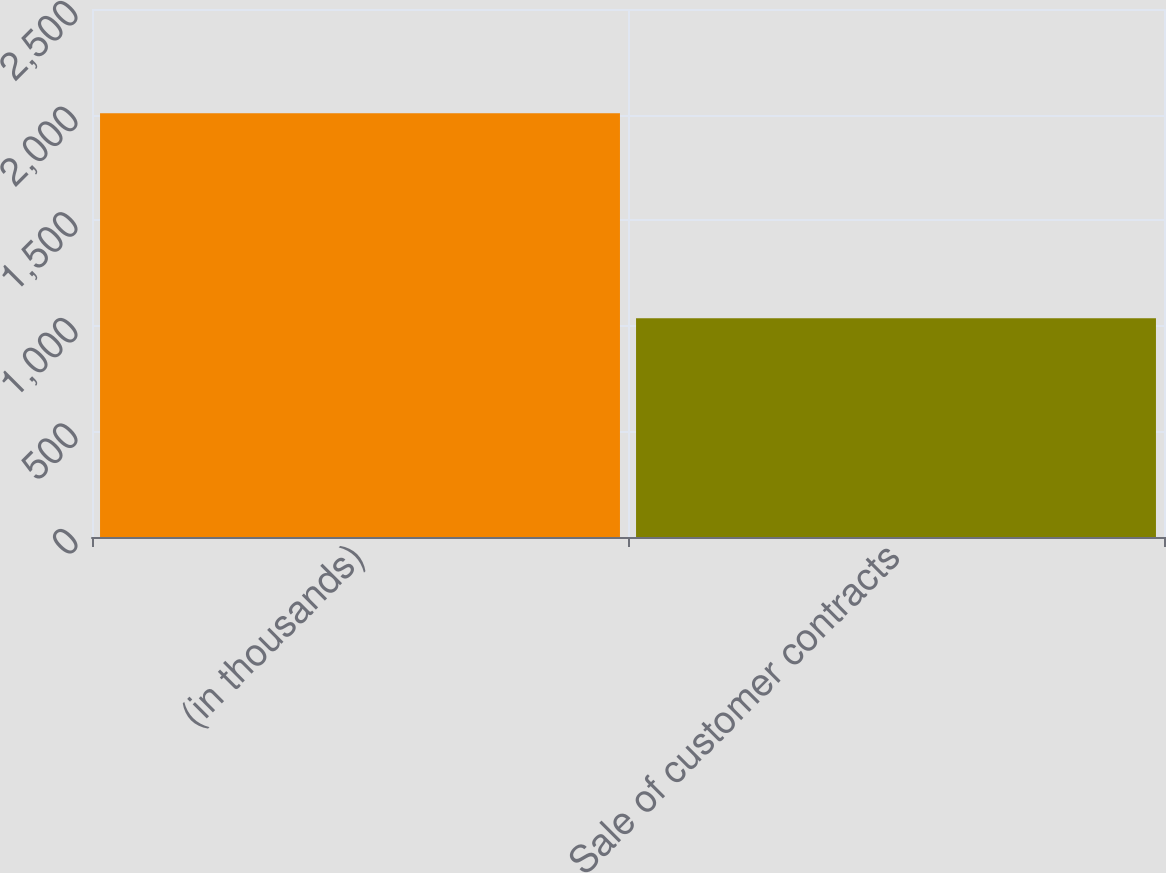Convert chart to OTSL. <chart><loc_0><loc_0><loc_500><loc_500><bar_chart><fcel>(in thousands)<fcel>Sale of customer contracts<nl><fcel>2006<fcel>1036<nl></chart> 